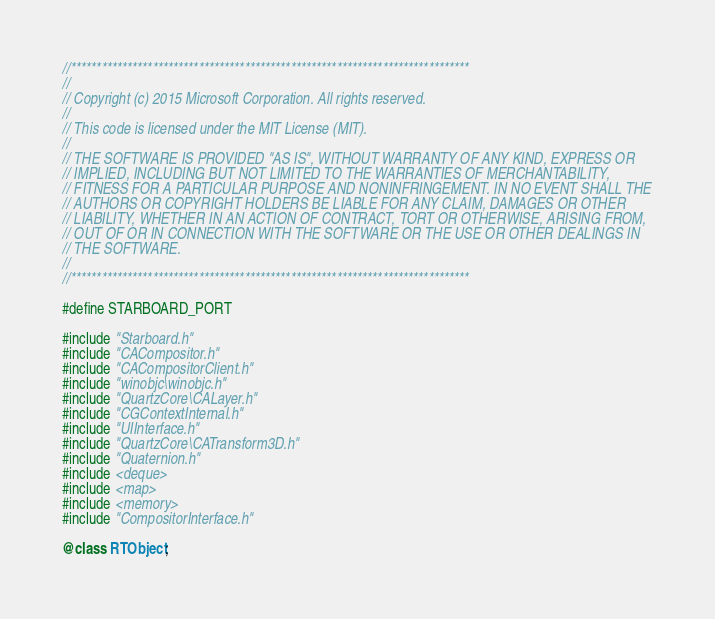Convert code to text. <code><loc_0><loc_0><loc_500><loc_500><_ObjectiveC_>//******************************************************************************
//
// Copyright (c) 2015 Microsoft Corporation. All rights reserved.
//
// This code is licensed under the MIT License (MIT).
//
// THE SOFTWARE IS PROVIDED "AS IS", WITHOUT WARRANTY OF ANY KIND, EXPRESS OR
// IMPLIED, INCLUDING BUT NOT LIMITED TO THE WARRANTIES OF MERCHANTABILITY,
// FITNESS FOR A PARTICULAR PURPOSE AND NONINFRINGEMENT. IN NO EVENT SHALL THE
// AUTHORS OR COPYRIGHT HOLDERS BE LIABLE FOR ANY CLAIM, DAMAGES OR OTHER
// LIABILITY, WHETHER IN AN ACTION OF CONTRACT, TORT OR OTHERWISE, ARISING FROM,
// OUT OF OR IN CONNECTION WITH THE SOFTWARE OR THE USE OR OTHER DEALINGS IN
// THE SOFTWARE.
//
//******************************************************************************

#define STARBOARD_PORT

#include "Starboard.h"
#include "CACompositor.h"
#include "CACompositorClient.h"
#include "winobjc\winobjc.h"
#include "QuartzCore\CALayer.h"
#include "CGContextInternal.h"
#include "UIInterface.h"
#include "QuartzCore\CATransform3D.h"
#include "Quaternion.h"
#include <deque>
#include <map>
#include <memory>
#include "CompositorInterface.h"

@class RTObject;
</code> 